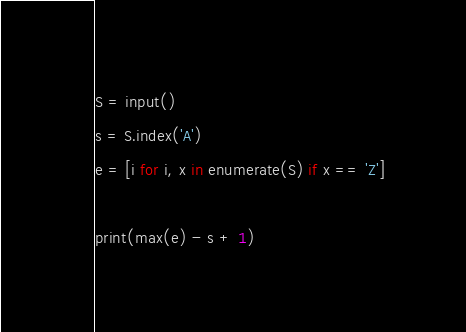<code> <loc_0><loc_0><loc_500><loc_500><_Python_>S = input()
s = S.index('A')
e = [i for i, x in enumerate(S) if x == 'Z']

print(max(e) - s + 1)</code> 